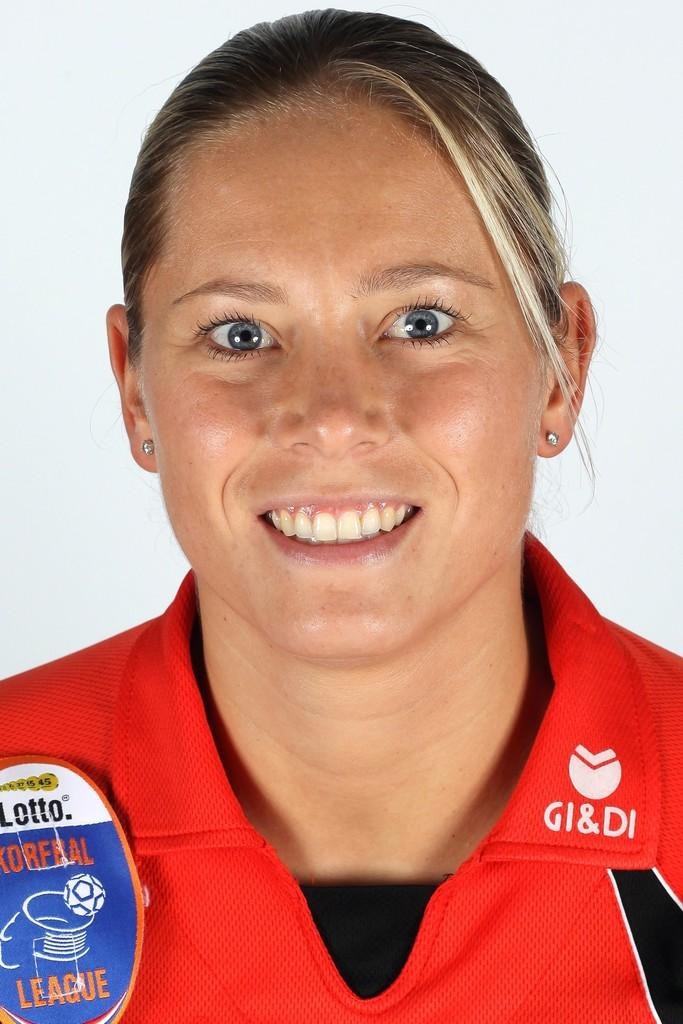<image>
Relay a brief, clear account of the picture shown. woman in red with gi&di on shirt and a patch with a soccer ball and word league on it 